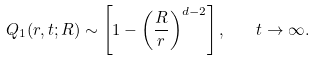Convert formula to latex. <formula><loc_0><loc_0><loc_500><loc_500>Q _ { 1 } ( r , t ; R ) \sim \left [ 1 - \left ( \frac { R } { r } \right ) ^ { d - 2 } \right ] , \quad t \to \infty .</formula> 